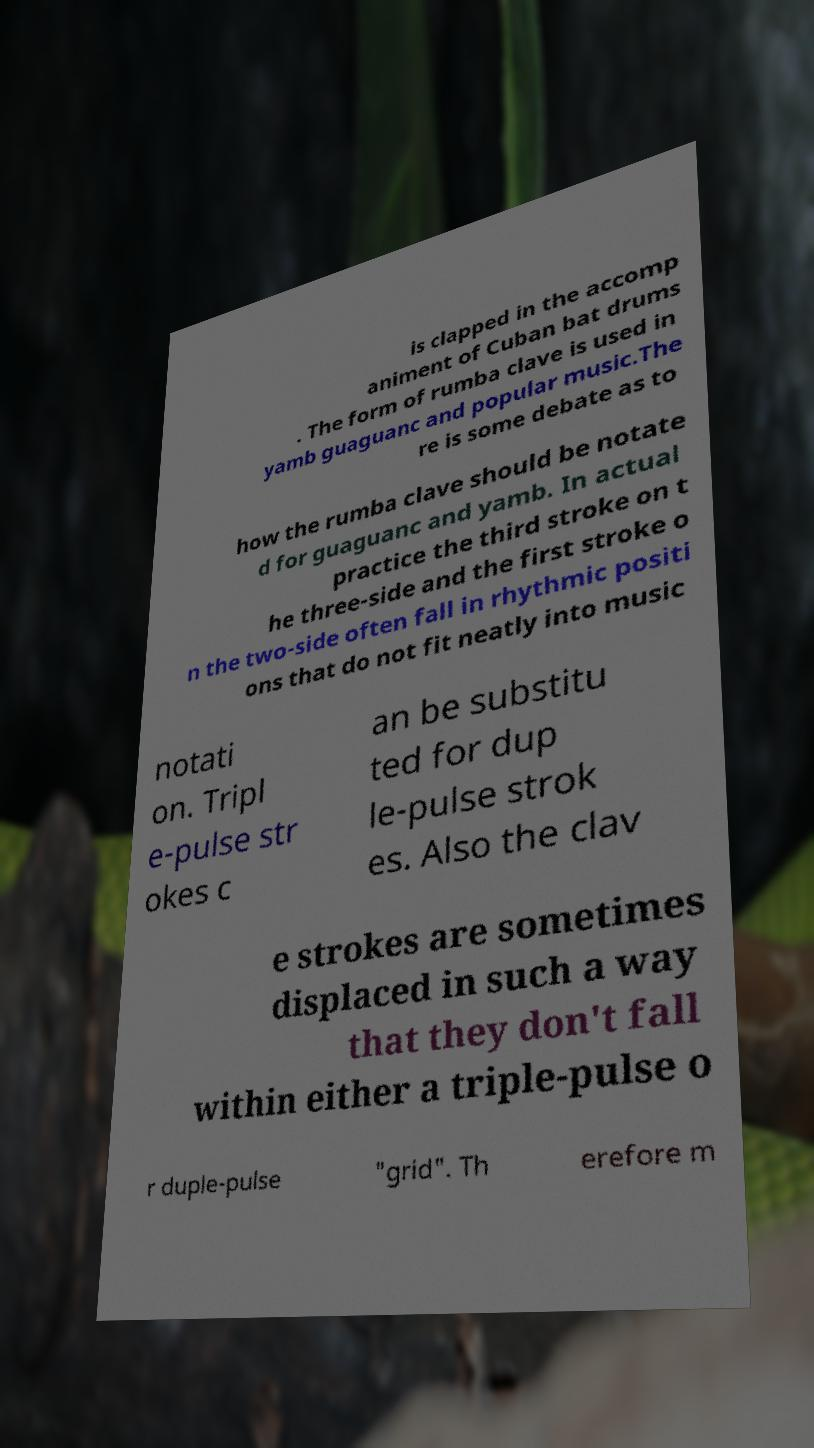I need the written content from this picture converted into text. Can you do that? is clapped in the accomp animent of Cuban bat drums . The form of rumba clave is used in yamb guaguanc and popular music.The re is some debate as to how the rumba clave should be notate d for guaguanc and yamb. In actual practice the third stroke on t he three-side and the first stroke o n the two-side often fall in rhythmic positi ons that do not fit neatly into music notati on. Tripl e-pulse str okes c an be substitu ted for dup le-pulse strok es. Also the clav e strokes are sometimes displaced in such a way that they don't fall within either a triple-pulse o r duple-pulse "grid". Th erefore m 